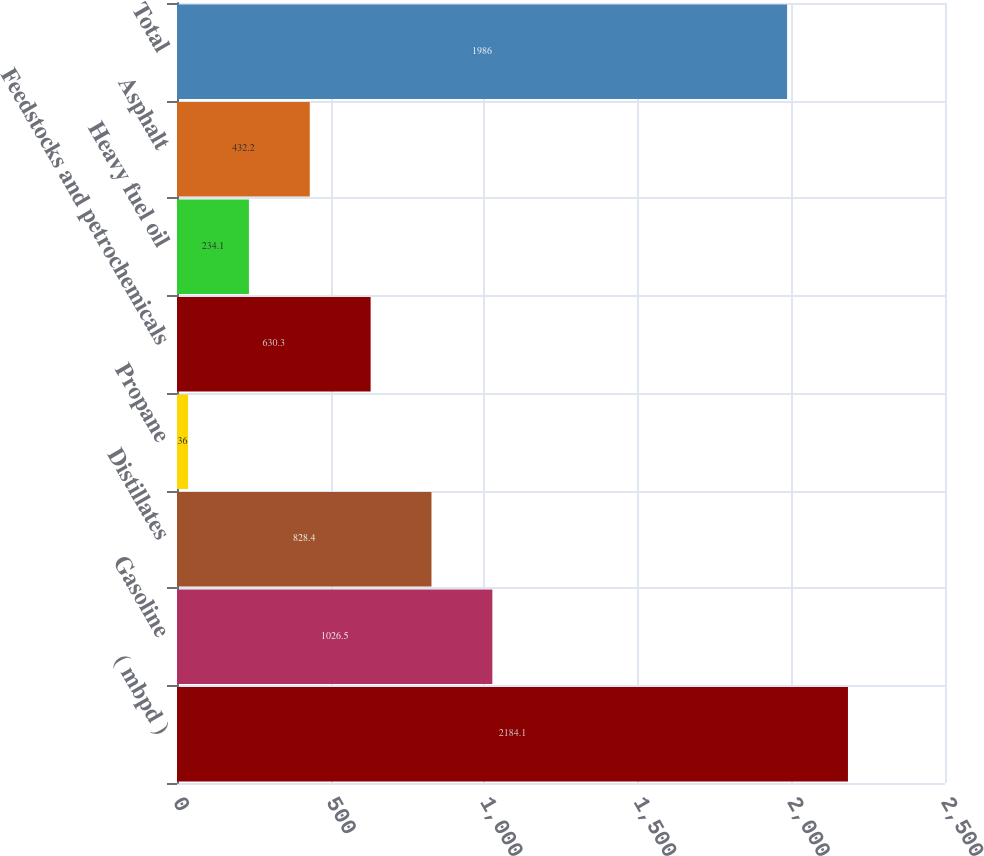Convert chart. <chart><loc_0><loc_0><loc_500><loc_500><bar_chart><fcel>( mbpd )<fcel>Gasoline<fcel>Distillates<fcel>Propane<fcel>Feedstocks and petrochemicals<fcel>Heavy fuel oil<fcel>Asphalt<fcel>Total<nl><fcel>2184.1<fcel>1026.5<fcel>828.4<fcel>36<fcel>630.3<fcel>234.1<fcel>432.2<fcel>1986<nl></chart> 